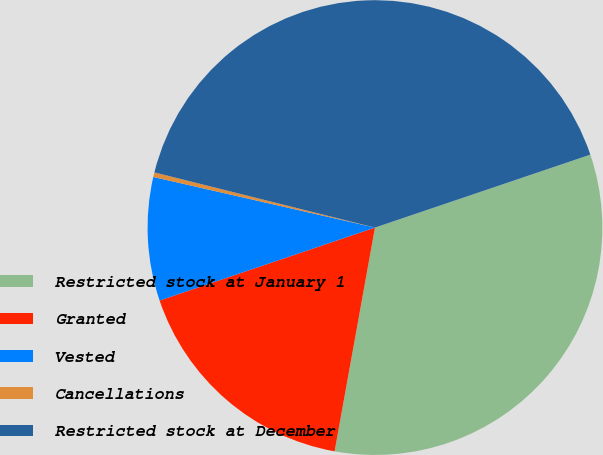<chart> <loc_0><loc_0><loc_500><loc_500><pie_chart><fcel>Restricted stock at January 1<fcel>Granted<fcel>Vested<fcel>Cancellations<fcel>Restricted stock at December<nl><fcel>33.04%<fcel>16.96%<fcel>8.77%<fcel>0.33%<fcel>40.9%<nl></chart> 